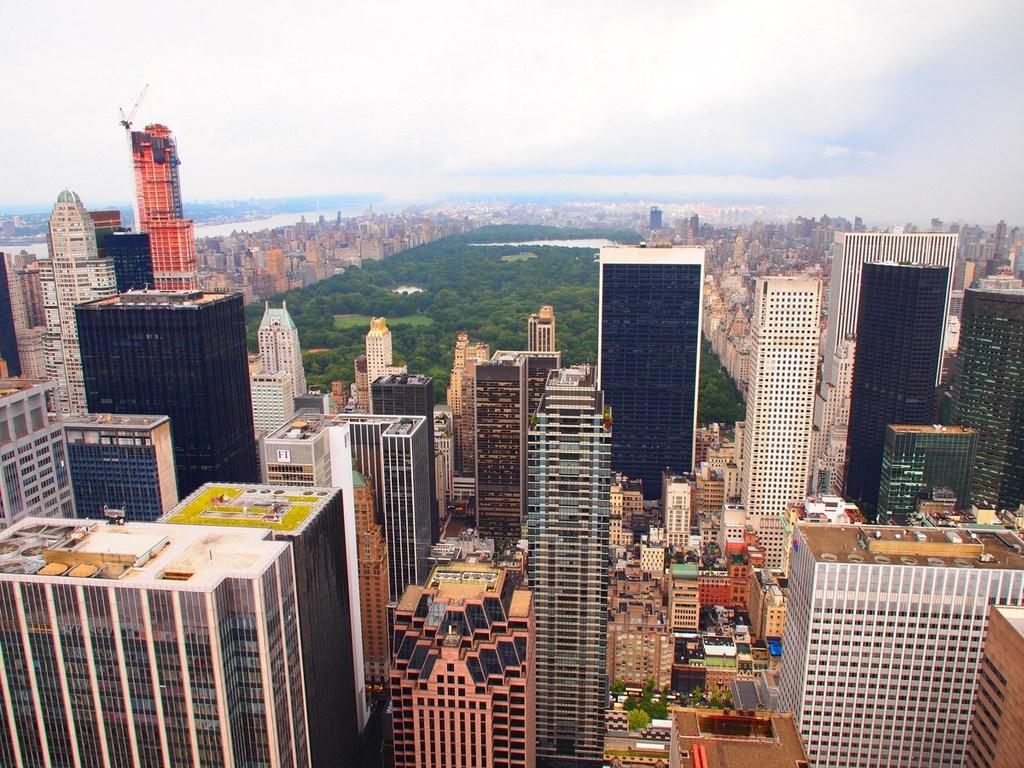What perspective is the image taken from? The image is captured from a top view. What type of structures can be seen in the image? There are tall buildings in the image. What is visible behind the tall buildings? There is greenery behind the tall buildings. How are the tall buildings situated in relation to the greenery? There are many buildings around the greenery. What type of destruction can be seen in the image? There is no destruction visible in the image; it features tall buildings and greenery. How does the dust affect the visibility of the buildings in the image? There is no dust present in the image, so it does not affect the visibility of the buildings. 